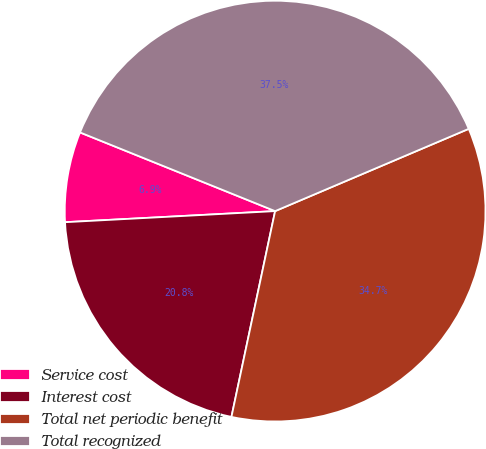<chart> <loc_0><loc_0><loc_500><loc_500><pie_chart><fcel>Service cost<fcel>Interest cost<fcel>Total net periodic benefit<fcel>Total recognized<nl><fcel>6.94%<fcel>20.83%<fcel>34.72%<fcel>37.5%<nl></chart> 